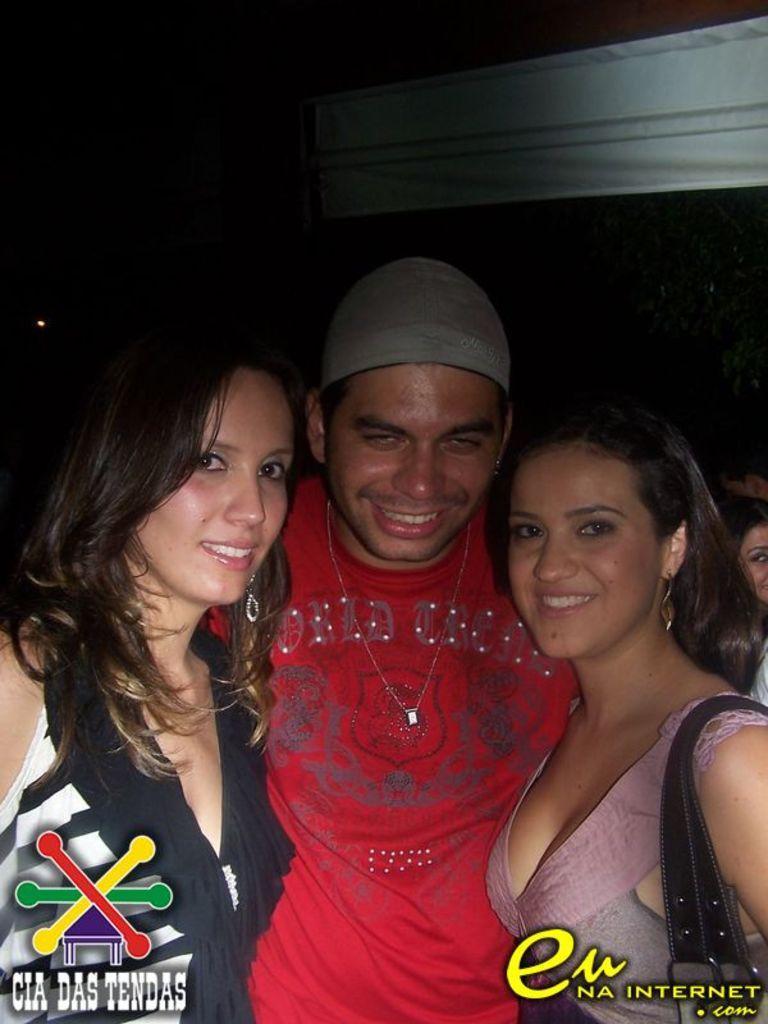Please provide a concise description of this image. In this image a man wearing red t-shirt and cap is standing in the middle of the image. Beside him there are two girls. They all are smiling. In the background there are few other people. The background is dark. 